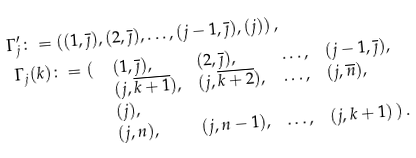Convert formula to latex. <formula><loc_0><loc_0><loc_500><loc_500>& \, \Gamma _ { j } ^ { \prime } \colon = ( ( 1 , \overline { \jmath } ) , ( 2 , \overline { \jmath } ) , \dots , ( j - 1 , \overline { \jmath } ) , ( j ) ) \, , \\ & \begin{array} { l l l l l l } \Gamma _ { j } ( k ) \colon = ( \, & ( 1 , \overline { \jmath } ) , & ( 2 , \overline { \jmath } ) , & \dots , & ( j - 1 , \overline { \jmath } ) , \\ & ( j , \overline { k + 1 } ) , & ( j , \overline { k + 2 } ) , & \dots , & ( j , \overline { n } ) , \\ & ( j ) , \\ & ( j , n ) , & ( j , n - 1 ) , & \dots , & ( j , k + 1 ) \, ) \, . \end{array}</formula> 